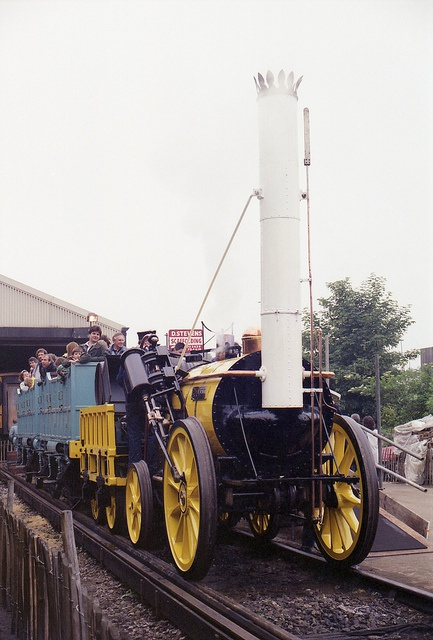Describe the objects in this image and their specific colors. I can see train in lightgray, black, gray, and olive tones, people in lightgray, gray, black, and darkgray tones, people in lightgray, gray, black, and darkgray tones, people in lightgray, gray, purple, darkgray, and pink tones, and people in lightgray, gray, darkgray, and brown tones in this image. 